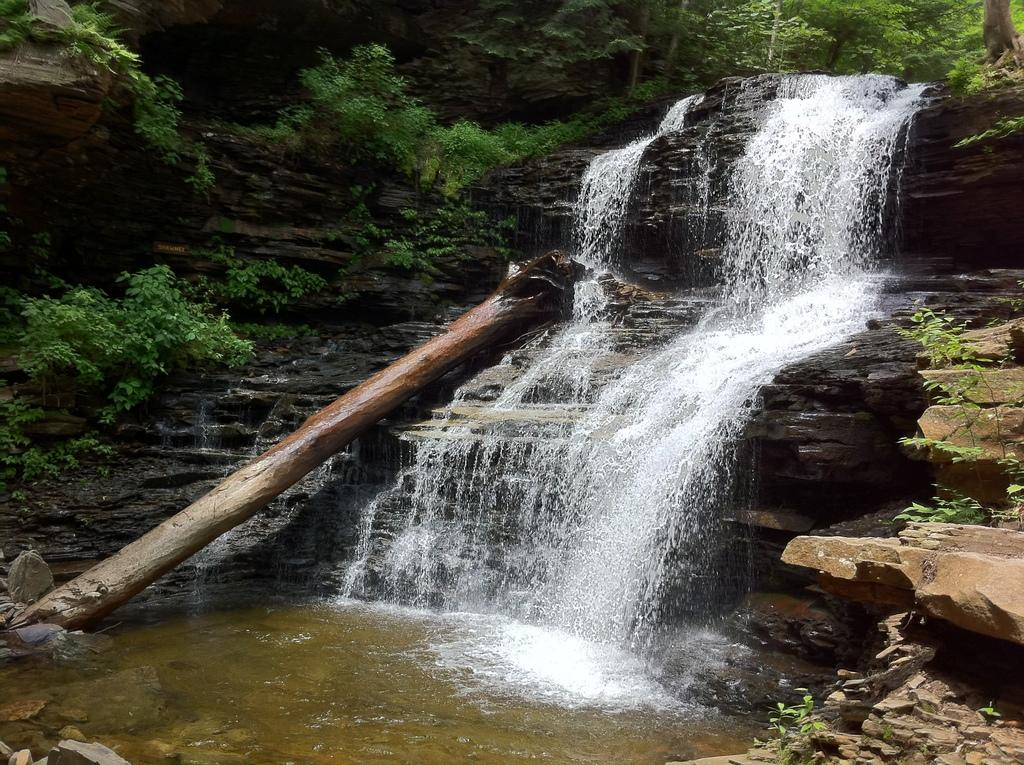What natural feature is the main subject of the image? There is a waterfall in the image. What else can be seen in the image besides the waterfall? There are rocks and green trees in the image. What type of riddle can be seen growing on the rocks near the waterfall in the image? There is no riddle present in the image; it features a waterfall, rocks, and green trees. Can you tell me how many seeds are visible on the trees in the image? There is no mention of seeds on the trees in the image, only that they are green. 